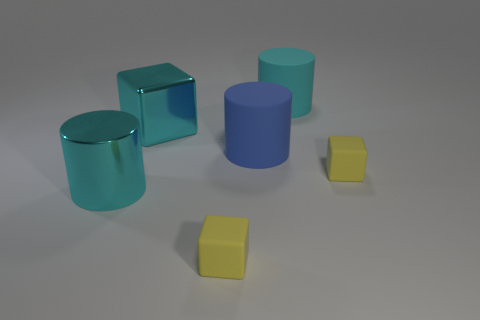Subtract all big cyan shiny cylinders. How many cylinders are left? 2 Add 1 cyan matte cylinders. How many objects exist? 7 Subtract all cyan cylinders. How many cylinders are left? 1 Subtract 3 cylinders. How many cylinders are left? 0 Subtract all large cubes. Subtract all tiny yellow cubes. How many objects are left? 3 Add 1 rubber cylinders. How many rubber cylinders are left? 3 Add 5 big yellow balls. How many big yellow balls exist? 5 Subtract 0 red blocks. How many objects are left? 6 Subtract all purple blocks. Subtract all cyan cylinders. How many blocks are left? 3 Subtract all blue blocks. How many red cylinders are left? 0 